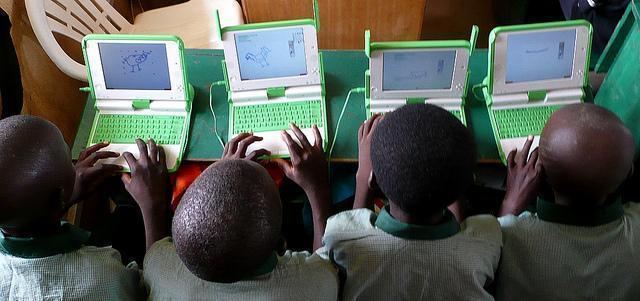Why are all the boys dressed alike?
Select the correct answer and articulate reasoning with the following format: 'Answer: answer
Rationale: rationale.'
Options: For fun, they're siblings, for halloween, dress code. Answer: dress code.
Rationale: The boys are all sitting in front of computers together. schools have computers for students. schools sometimes have dress codes. 